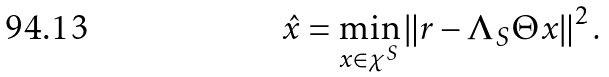Convert formula to latex. <formula><loc_0><loc_0><loc_500><loc_500>\hat { x } = \min _ { x \in \chi ^ { S } } \left \| r - \Lambda _ { S } \Theta x \right \| ^ { 2 } .</formula> 